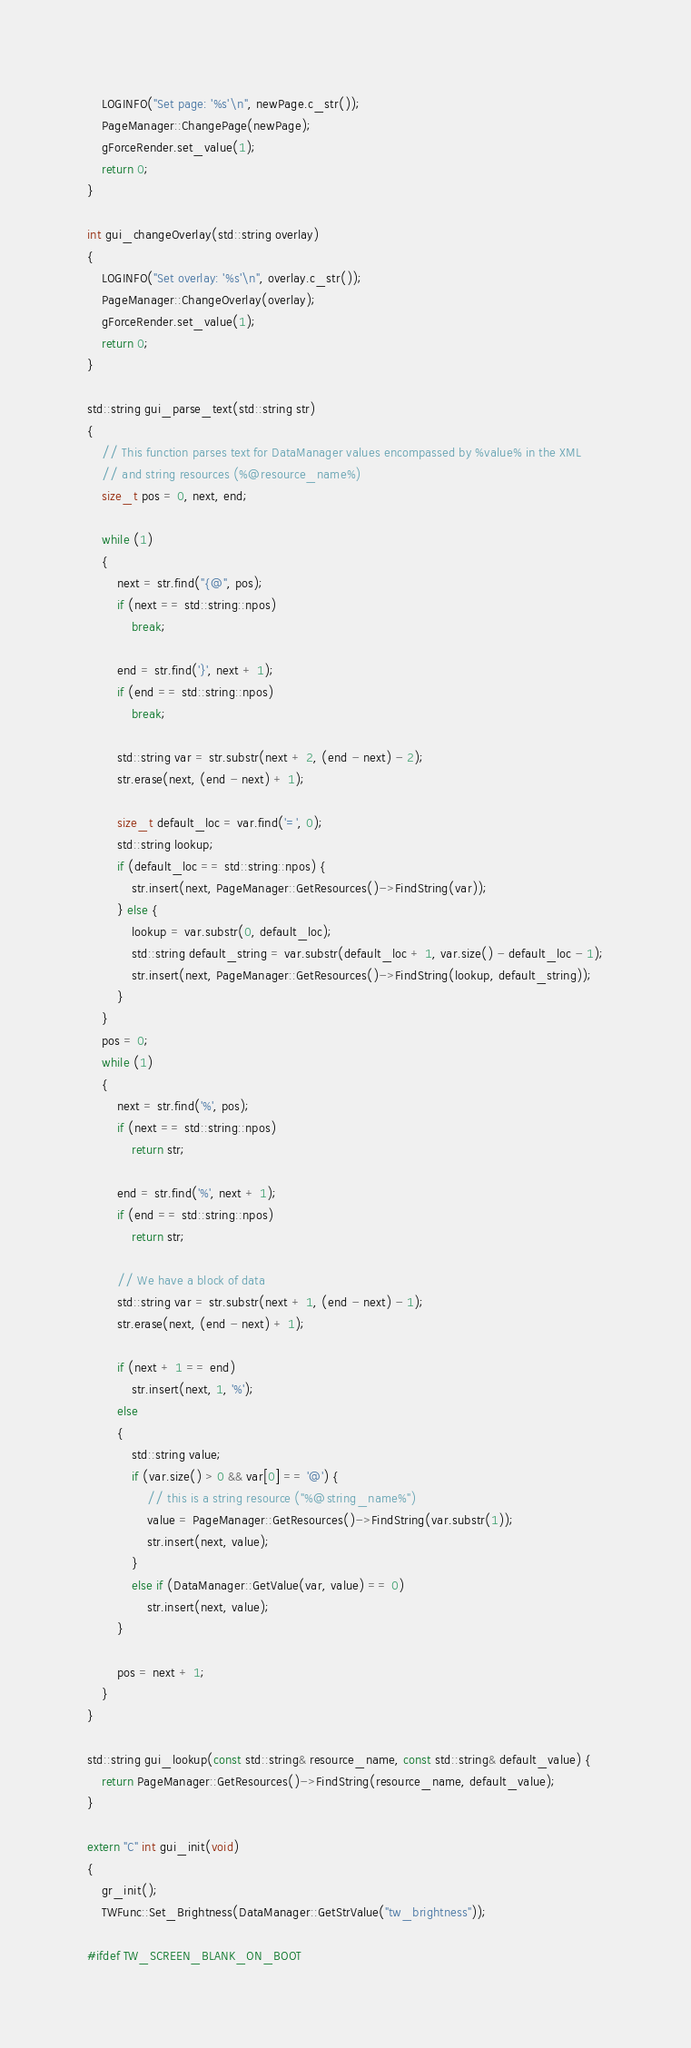Convert code to text. <code><loc_0><loc_0><loc_500><loc_500><_C++_>	LOGINFO("Set page: '%s'\n", newPage.c_str());
	PageManager::ChangePage(newPage);
	gForceRender.set_value(1);
	return 0;
}

int gui_changeOverlay(std::string overlay)
{
	LOGINFO("Set overlay: '%s'\n", overlay.c_str());
	PageManager::ChangeOverlay(overlay);
	gForceRender.set_value(1);
	return 0;
}

std::string gui_parse_text(std::string str)
{
	// This function parses text for DataManager values encompassed by %value% in the XML
	// and string resources (%@resource_name%)
	size_t pos = 0, next, end;

	while (1)
	{
		next = str.find("{@", pos);
		if (next == std::string::npos)
			break;

		end = str.find('}', next + 1);
		if (end == std::string::npos)
			break;

		std::string var = str.substr(next + 2, (end - next) - 2);
		str.erase(next, (end - next) + 1);

		size_t default_loc = var.find('=', 0);
		std::string lookup;
		if (default_loc == std::string::npos) {
			str.insert(next, PageManager::GetResources()->FindString(var));
		} else {
			lookup = var.substr(0, default_loc);
			std::string default_string = var.substr(default_loc + 1, var.size() - default_loc - 1);
			str.insert(next, PageManager::GetResources()->FindString(lookup, default_string));
		}
	}
	pos = 0;
	while (1)
	{
		next = str.find('%', pos);
		if (next == std::string::npos)
			return str;

		end = str.find('%', next + 1);
		if (end == std::string::npos)
			return str;

		// We have a block of data
		std::string var = str.substr(next + 1, (end - next) - 1);
		str.erase(next, (end - next) + 1);

		if (next + 1 == end)
			str.insert(next, 1, '%');
		else
		{
			std::string value;
			if (var.size() > 0 && var[0] == '@') {
				// this is a string resource ("%@string_name%")
				value = PageManager::GetResources()->FindString(var.substr(1));
				str.insert(next, value);
			}
			else if (DataManager::GetValue(var, value) == 0)
				str.insert(next, value);
		}

		pos = next + 1;
	}
}

std::string gui_lookup(const std::string& resource_name, const std::string& default_value) {
	return PageManager::GetResources()->FindString(resource_name, default_value);
}

extern "C" int gui_init(void)
{
	gr_init();
	TWFunc::Set_Brightness(DataManager::GetStrValue("tw_brightness"));

#ifdef TW_SCREEN_BLANK_ON_BOOT</code> 